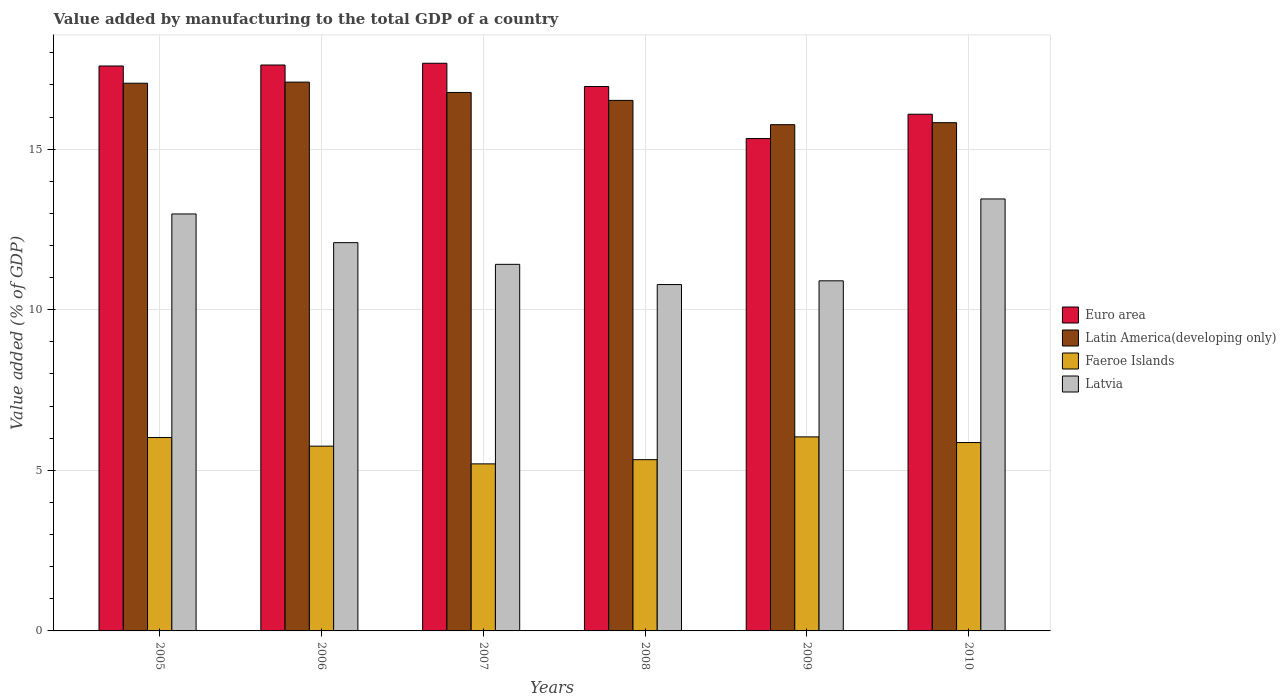How many bars are there on the 4th tick from the left?
Offer a very short reply. 4. How many bars are there on the 4th tick from the right?
Your answer should be compact. 4. What is the value added by manufacturing to the total GDP in Faeroe Islands in 2005?
Keep it short and to the point. 6.02. Across all years, what is the maximum value added by manufacturing to the total GDP in Faeroe Islands?
Provide a succinct answer. 6.04. Across all years, what is the minimum value added by manufacturing to the total GDP in Latin America(developing only)?
Keep it short and to the point. 15.76. In which year was the value added by manufacturing to the total GDP in Latin America(developing only) maximum?
Ensure brevity in your answer.  2006. What is the total value added by manufacturing to the total GDP in Latin America(developing only) in the graph?
Ensure brevity in your answer.  99. What is the difference between the value added by manufacturing to the total GDP in Latin America(developing only) in 2006 and that in 2008?
Make the answer very short. 0.57. What is the difference between the value added by manufacturing to the total GDP in Euro area in 2010 and the value added by manufacturing to the total GDP in Latvia in 2009?
Your answer should be very brief. 5.19. What is the average value added by manufacturing to the total GDP in Faeroe Islands per year?
Make the answer very short. 5.7. In the year 2007, what is the difference between the value added by manufacturing to the total GDP in Latvia and value added by manufacturing to the total GDP in Faeroe Islands?
Your response must be concise. 6.21. What is the ratio of the value added by manufacturing to the total GDP in Euro area in 2007 to that in 2009?
Offer a very short reply. 1.15. What is the difference between the highest and the second highest value added by manufacturing to the total GDP in Euro area?
Keep it short and to the point. 0.05. What is the difference between the highest and the lowest value added by manufacturing to the total GDP in Euro area?
Your answer should be very brief. 2.34. In how many years, is the value added by manufacturing to the total GDP in Latvia greater than the average value added by manufacturing to the total GDP in Latvia taken over all years?
Ensure brevity in your answer.  3. Is the sum of the value added by manufacturing to the total GDP in Euro area in 2005 and 2006 greater than the maximum value added by manufacturing to the total GDP in Faeroe Islands across all years?
Make the answer very short. Yes. What does the 4th bar from the left in 2008 represents?
Keep it short and to the point. Latvia. What does the 3rd bar from the right in 2006 represents?
Your response must be concise. Latin America(developing only). Is it the case that in every year, the sum of the value added by manufacturing to the total GDP in Latin America(developing only) and value added by manufacturing to the total GDP in Euro area is greater than the value added by manufacturing to the total GDP in Latvia?
Ensure brevity in your answer.  Yes. What is the difference between two consecutive major ticks on the Y-axis?
Ensure brevity in your answer.  5. Are the values on the major ticks of Y-axis written in scientific E-notation?
Keep it short and to the point. No. Does the graph contain any zero values?
Your answer should be very brief. No. Where does the legend appear in the graph?
Keep it short and to the point. Center right. How many legend labels are there?
Your response must be concise. 4. How are the legend labels stacked?
Provide a succinct answer. Vertical. What is the title of the graph?
Your answer should be very brief. Value added by manufacturing to the total GDP of a country. What is the label or title of the Y-axis?
Your answer should be compact. Value added (% of GDP). What is the Value added (% of GDP) of Euro area in 2005?
Provide a short and direct response. 17.59. What is the Value added (% of GDP) in Latin America(developing only) in 2005?
Provide a short and direct response. 17.05. What is the Value added (% of GDP) in Faeroe Islands in 2005?
Your answer should be very brief. 6.02. What is the Value added (% of GDP) in Latvia in 2005?
Offer a very short reply. 12.98. What is the Value added (% of GDP) of Euro area in 2006?
Make the answer very short. 17.62. What is the Value added (% of GDP) of Latin America(developing only) in 2006?
Your answer should be very brief. 17.09. What is the Value added (% of GDP) in Faeroe Islands in 2006?
Your response must be concise. 5.75. What is the Value added (% of GDP) of Latvia in 2006?
Give a very brief answer. 12.09. What is the Value added (% of GDP) in Euro area in 2007?
Keep it short and to the point. 17.67. What is the Value added (% of GDP) in Latin America(developing only) in 2007?
Offer a very short reply. 16.76. What is the Value added (% of GDP) in Faeroe Islands in 2007?
Your answer should be compact. 5.2. What is the Value added (% of GDP) in Latvia in 2007?
Keep it short and to the point. 11.41. What is the Value added (% of GDP) in Euro area in 2008?
Make the answer very short. 16.95. What is the Value added (% of GDP) in Latin America(developing only) in 2008?
Offer a very short reply. 16.52. What is the Value added (% of GDP) of Faeroe Islands in 2008?
Provide a succinct answer. 5.33. What is the Value added (% of GDP) in Latvia in 2008?
Make the answer very short. 10.78. What is the Value added (% of GDP) of Euro area in 2009?
Give a very brief answer. 15.33. What is the Value added (% of GDP) of Latin America(developing only) in 2009?
Give a very brief answer. 15.76. What is the Value added (% of GDP) of Faeroe Islands in 2009?
Your answer should be compact. 6.04. What is the Value added (% of GDP) of Latvia in 2009?
Keep it short and to the point. 10.9. What is the Value added (% of GDP) of Euro area in 2010?
Provide a short and direct response. 16.09. What is the Value added (% of GDP) of Latin America(developing only) in 2010?
Offer a very short reply. 15.82. What is the Value added (% of GDP) in Faeroe Islands in 2010?
Your answer should be very brief. 5.86. What is the Value added (% of GDP) in Latvia in 2010?
Your answer should be compact. 13.45. Across all years, what is the maximum Value added (% of GDP) in Euro area?
Make the answer very short. 17.67. Across all years, what is the maximum Value added (% of GDP) of Latin America(developing only)?
Provide a short and direct response. 17.09. Across all years, what is the maximum Value added (% of GDP) in Faeroe Islands?
Ensure brevity in your answer.  6.04. Across all years, what is the maximum Value added (% of GDP) of Latvia?
Keep it short and to the point. 13.45. Across all years, what is the minimum Value added (% of GDP) in Euro area?
Provide a short and direct response. 15.33. Across all years, what is the minimum Value added (% of GDP) of Latin America(developing only)?
Your response must be concise. 15.76. Across all years, what is the minimum Value added (% of GDP) of Faeroe Islands?
Your response must be concise. 5.2. Across all years, what is the minimum Value added (% of GDP) of Latvia?
Your answer should be compact. 10.78. What is the total Value added (% of GDP) in Euro area in the graph?
Offer a terse response. 101.24. What is the total Value added (% of GDP) of Latin America(developing only) in the graph?
Your answer should be compact. 99. What is the total Value added (% of GDP) of Faeroe Islands in the graph?
Provide a succinct answer. 34.21. What is the total Value added (% of GDP) in Latvia in the graph?
Provide a short and direct response. 71.62. What is the difference between the Value added (% of GDP) of Euro area in 2005 and that in 2006?
Your response must be concise. -0.03. What is the difference between the Value added (% of GDP) of Latin America(developing only) in 2005 and that in 2006?
Provide a succinct answer. -0.03. What is the difference between the Value added (% of GDP) of Faeroe Islands in 2005 and that in 2006?
Offer a terse response. 0.27. What is the difference between the Value added (% of GDP) in Latvia in 2005 and that in 2006?
Offer a very short reply. 0.89. What is the difference between the Value added (% of GDP) of Euro area in 2005 and that in 2007?
Offer a very short reply. -0.09. What is the difference between the Value added (% of GDP) of Latin America(developing only) in 2005 and that in 2007?
Your response must be concise. 0.29. What is the difference between the Value added (% of GDP) in Faeroe Islands in 2005 and that in 2007?
Your answer should be very brief. 0.82. What is the difference between the Value added (% of GDP) in Latvia in 2005 and that in 2007?
Your answer should be compact. 1.57. What is the difference between the Value added (% of GDP) of Euro area in 2005 and that in 2008?
Give a very brief answer. 0.64. What is the difference between the Value added (% of GDP) of Latin America(developing only) in 2005 and that in 2008?
Offer a terse response. 0.53. What is the difference between the Value added (% of GDP) in Faeroe Islands in 2005 and that in 2008?
Make the answer very short. 0.69. What is the difference between the Value added (% of GDP) of Latvia in 2005 and that in 2008?
Offer a terse response. 2.2. What is the difference between the Value added (% of GDP) of Euro area in 2005 and that in 2009?
Give a very brief answer. 2.26. What is the difference between the Value added (% of GDP) of Latin America(developing only) in 2005 and that in 2009?
Your answer should be compact. 1.29. What is the difference between the Value added (% of GDP) of Faeroe Islands in 2005 and that in 2009?
Give a very brief answer. -0.02. What is the difference between the Value added (% of GDP) in Latvia in 2005 and that in 2009?
Ensure brevity in your answer.  2.08. What is the difference between the Value added (% of GDP) of Euro area in 2005 and that in 2010?
Offer a terse response. 1.5. What is the difference between the Value added (% of GDP) in Latin America(developing only) in 2005 and that in 2010?
Your response must be concise. 1.23. What is the difference between the Value added (% of GDP) in Faeroe Islands in 2005 and that in 2010?
Provide a short and direct response. 0.16. What is the difference between the Value added (% of GDP) of Latvia in 2005 and that in 2010?
Provide a short and direct response. -0.47. What is the difference between the Value added (% of GDP) in Euro area in 2006 and that in 2007?
Your answer should be very brief. -0.05. What is the difference between the Value added (% of GDP) in Latin America(developing only) in 2006 and that in 2007?
Offer a terse response. 0.32. What is the difference between the Value added (% of GDP) in Faeroe Islands in 2006 and that in 2007?
Provide a succinct answer. 0.55. What is the difference between the Value added (% of GDP) of Latvia in 2006 and that in 2007?
Your answer should be compact. 0.68. What is the difference between the Value added (% of GDP) in Euro area in 2006 and that in 2008?
Your answer should be very brief. 0.67. What is the difference between the Value added (% of GDP) of Latin America(developing only) in 2006 and that in 2008?
Make the answer very short. 0.57. What is the difference between the Value added (% of GDP) of Faeroe Islands in 2006 and that in 2008?
Offer a very short reply. 0.42. What is the difference between the Value added (% of GDP) of Latvia in 2006 and that in 2008?
Your answer should be very brief. 1.3. What is the difference between the Value added (% of GDP) of Euro area in 2006 and that in 2009?
Make the answer very short. 2.29. What is the difference between the Value added (% of GDP) in Latin America(developing only) in 2006 and that in 2009?
Offer a terse response. 1.33. What is the difference between the Value added (% of GDP) in Faeroe Islands in 2006 and that in 2009?
Your answer should be very brief. -0.29. What is the difference between the Value added (% of GDP) in Latvia in 2006 and that in 2009?
Keep it short and to the point. 1.19. What is the difference between the Value added (% of GDP) in Euro area in 2006 and that in 2010?
Keep it short and to the point. 1.53. What is the difference between the Value added (% of GDP) in Latin America(developing only) in 2006 and that in 2010?
Provide a short and direct response. 1.26. What is the difference between the Value added (% of GDP) in Faeroe Islands in 2006 and that in 2010?
Offer a terse response. -0.11. What is the difference between the Value added (% of GDP) in Latvia in 2006 and that in 2010?
Offer a terse response. -1.36. What is the difference between the Value added (% of GDP) of Euro area in 2007 and that in 2008?
Provide a succinct answer. 0.72. What is the difference between the Value added (% of GDP) of Latin America(developing only) in 2007 and that in 2008?
Your response must be concise. 0.25. What is the difference between the Value added (% of GDP) of Faeroe Islands in 2007 and that in 2008?
Offer a very short reply. -0.13. What is the difference between the Value added (% of GDP) in Latvia in 2007 and that in 2008?
Offer a very short reply. 0.63. What is the difference between the Value added (% of GDP) of Euro area in 2007 and that in 2009?
Offer a terse response. 2.34. What is the difference between the Value added (% of GDP) in Latin America(developing only) in 2007 and that in 2009?
Offer a very short reply. 1. What is the difference between the Value added (% of GDP) in Faeroe Islands in 2007 and that in 2009?
Make the answer very short. -0.84. What is the difference between the Value added (% of GDP) of Latvia in 2007 and that in 2009?
Make the answer very short. 0.51. What is the difference between the Value added (% of GDP) in Euro area in 2007 and that in 2010?
Your answer should be very brief. 1.59. What is the difference between the Value added (% of GDP) in Latin America(developing only) in 2007 and that in 2010?
Ensure brevity in your answer.  0.94. What is the difference between the Value added (% of GDP) in Faeroe Islands in 2007 and that in 2010?
Offer a terse response. -0.66. What is the difference between the Value added (% of GDP) of Latvia in 2007 and that in 2010?
Your answer should be very brief. -2.04. What is the difference between the Value added (% of GDP) in Euro area in 2008 and that in 2009?
Your response must be concise. 1.62. What is the difference between the Value added (% of GDP) in Latin America(developing only) in 2008 and that in 2009?
Ensure brevity in your answer.  0.76. What is the difference between the Value added (% of GDP) of Faeroe Islands in 2008 and that in 2009?
Offer a terse response. -0.71. What is the difference between the Value added (% of GDP) in Latvia in 2008 and that in 2009?
Give a very brief answer. -0.12. What is the difference between the Value added (% of GDP) of Euro area in 2008 and that in 2010?
Keep it short and to the point. 0.86. What is the difference between the Value added (% of GDP) of Latin America(developing only) in 2008 and that in 2010?
Your answer should be very brief. 0.69. What is the difference between the Value added (% of GDP) of Faeroe Islands in 2008 and that in 2010?
Your answer should be very brief. -0.53. What is the difference between the Value added (% of GDP) of Latvia in 2008 and that in 2010?
Provide a short and direct response. -2.66. What is the difference between the Value added (% of GDP) in Euro area in 2009 and that in 2010?
Offer a terse response. -0.76. What is the difference between the Value added (% of GDP) of Latin America(developing only) in 2009 and that in 2010?
Your answer should be very brief. -0.06. What is the difference between the Value added (% of GDP) of Faeroe Islands in 2009 and that in 2010?
Provide a succinct answer. 0.18. What is the difference between the Value added (% of GDP) of Latvia in 2009 and that in 2010?
Your answer should be very brief. -2.55. What is the difference between the Value added (% of GDP) of Euro area in 2005 and the Value added (% of GDP) of Latin America(developing only) in 2006?
Keep it short and to the point. 0.5. What is the difference between the Value added (% of GDP) of Euro area in 2005 and the Value added (% of GDP) of Faeroe Islands in 2006?
Provide a succinct answer. 11.84. What is the difference between the Value added (% of GDP) in Euro area in 2005 and the Value added (% of GDP) in Latvia in 2006?
Provide a succinct answer. 5.5. What is the difference between the Value added (% of GDP) in Latin America(developing only) in 2005 and the Value added (% of GDP) in Faeroe Islands in 2006?
Provide a short and direct response. 11.3. What is the difference between the Value added (% of GDP) of Latin America(developing only) in 2005 and the Value added (% of GDP) of Latvia in 2006?
Your answer should be very brief. 4.96. What is the difference between the Value added (% of GDP) in Faeroe Islands in 2005 and the Value added (% of GDP) in Latvia in 2006?
Make the answer very short. -6.07. What is the difference between the Value added (% of GDP) in Euro area in 2005 and the Value added (% of GDP) in Latin America(developing only) in 2007?
Your answer should be very brief. 0.82. What is the difference between the Value added (% of GDP) of Euro area in 2005 and the Value added (% of GDP) of Faeroe Islands in 2007?
Your answer should be compact. 12.39. What is the difference between the Value added (% of GDP) in Euro area in 2005 and the Value added (% of GDP) in Latvia in 2007?
Offer a terse response. 6.18. What is the difference between the Value added (% of GDP) of Latin America(developing only) in 2005 and the Value added (% of GDP) of Faeroe Islands in 2007?
Make the answer very short. 11.85. What is the difference between the Value added (% of GDP) in Latin America(developing only) in 2005 and the Value added (% of GDP) in Latvia in 2007?
Your answer should be compact. 5.64. What is the difference between the Value added (% of GDP) of Faeroe Islands in 2005 and the Value added (% of GDP) of Latvia in 2007?
Your answer should be compact. -5.39. What is the difference between the Value added (% of GDP) in Euro area in 2005 and the Value added (% of GDP) in Latin America(developing only) in 2008?
Your response must be concise. 1.07. What is the difference between the Value added (% of GDP) in Euro area in 2005 and the Value added (% of GDP) in Faeroe Islands in 2008?
Provide a short and direct response. 12.26. What is the difference between the Value added (% of GDP) in Euro area in 2005 and the Value added (% of GDP) in Latvia in 2008?
Give a very brief answer. 6.8. What is the difference between the Value added (% of GDP) in Latin America(developing only) in 2005 and the Value added (% of GDP) in Faeroe Islands in 2008?
Your answer should be compact. 11.72. What is the difference between the Value added (% of GDP) of Latin America(developing only) in 2005 and the Value added (% of GDP) of Latvia in 2008?
Your answer should be compact. 6.27. What is the difference between the Value added (% of GDP) in Faeroe Islands in 2005 and the Value added (% of GDP) in Latvia in 2008?
Keep it short and to the point. -4.76. What is the difference between the Value added (% of GDP) in Euro area in 2005 and the Value added (% of GDP) in Latin America(developing only) in 2009?
Your response must be concise. 1.83. What is the difference between the Value added (% of GDP) of Euro area in 2005 and the Value added (% of GDP) of Faeroe Islands in 2009?
Provide a short and direct response. 11.55. What is the difference between the Value added (% of GDP) of Euro area in 2005 and the Value added (% of GDP) of Latvia in 2009?
Offer a very short reply. 6.69. What is the difference between the Value added (% of GDP) of Latin America(developing only) in 2005 and the Value added (% of GDP) of Faeroe Islands in 2009?
Make the answer very short. 11.01. What is the difference between the Value added (% of GDP) of Latin America(developing only) in 2005 and the Value added (% of GDP) of Latvia in 2009?
Your answer should be compact. 6.15. What is the difference between the Value added (% of GDP) of Faeroe Islands in 2005 and the Value added (% of GDP) of Latvia in 2009?
Your response must be concise. -4.88. What is the difference between the Value added (% of GDP) in Euro area in 2005 and the Value added (% of GDP) in Latin America(developing only) in 2010?
Your response must be concise. 1.76. What is the difference between the Value added (% of GDP) of Euro area in 2005 and the Value added (% of GDP) of Faeroe Islands in 2010?
Your response must be concise. 11.72. What is the difference between the Value added (% of GDP) of Euro area in 2005 and the Value added (% of GDP) of Latvia in 2010?
Your answer should be compact. 4.14. What is the difference between the Value added (% of GDP) in Latin America(developing only) in 2005 and the Value added (% of GDP) in Faeroe Islands in 2010?
Offer a terse response. 11.19. What is the difference between the Value added (% of GDP) of Latin America(developing only) in 2005 and the Value added (% of GDP) of Latvia in 2010?
Provide a short and direct response. 3.6. What is the difference between the Value added (% of GDP) of Faeroe Islands in 2005 and the Value added (% of GDP) of Latvia in 2010?
Your response must be concise. -7.43. What is the difference between the Value added (% of GDP) in Euro area in 2006 and the Value added (% of GDP) in Latin America(developing only) in 2007?
Your response must be concise. 0.85. What is the difference between the Value added (% of GDP) of Euro area in 2006 and the Value added (% of GDP) of Faeroe Islands in 2007?
Offer a terse response. 12.42. What is the difference between the Value added (% of GDP) in Euro area in 2006 and the Value added (% of GDP) in Latvia in 2007?
Give a very brief answer. 6.21. What is the difference between the Value added (% of GDP) of Latin America(developing only) in 2006 and the Value added (% of GDP) of Faeroe Islands in 2007?
Make the answer very short. 11.89. What is the difference between the Value added (% of GDP) in Latin America(developing only) in 2006 and the Value added (% of GDP) in Latvia in 2007?
Your response must be concise. 5.67. What is the difference between the Value added (% of GDP) of Faeroe Islands in 2006 and the Value added (% of GDP) of Latvia in 2007?
Your answer should be very brief. -5.66. What is the difference between the Value added (% of GDP) in Euro area in 2006 and the Value added (% of GDP) in Latin America(developing only) in 2008?
Make the answer very short. 1.1. What is the difference between the Value added (% of GDP) of Euro area in 2006 and the Value added (% of GDP) of Faeroe Islands in 2008?
Offer a terse response. 12.29. What is the difference between the Value added (% of GDP) of Euro area in 2006 and the Value added (% of GDP) of Latvia in 2008?
Offer a terse response. 6.83. What is the difference between the Value added (% of GDP) in Latin America(developing only) in 2006 and the Value added (% of GDP) in Faeroe Islands in 2008?
Your answer should be very brief. 11.75. What is the difference between the Value added (% of GDP) of Latin America(developing only) in 2006 and the Value added (% of GDP) of Latvia in 2008?
Your answer should be compact. 6.3. What is the difference between the Value added (% of GDP) in Faeroe Islands in 2006 and the Value added (% of GDP) in Latvia in 2008?
Ensure brevity in your answer.  -5.03. What is the difference between the Value added (% of GDP) in Euro area in 2006 and the Value added (% of GDP) in Latin America(developing only) in 2009?
Keep it short and to the point. 1.86. What is the difference between the Value added (% of GDP) in Euro area in 2006 and the Value added (% of GDP) in Faeroe Islands in 2009?
Your response must be concise. 11.58. What is the difference between the Value added (% of GDP) in Euro area in 2006 and the Value added (% of GDP) in Latvia in 2009?
Make the answer very short. 6.72. What is the difference between the Value added (% of GDP) of Latin America(developing only) in 2006 and the Value added (% of GDP) of Faeroe Islands in 2009?
Keep it short and to the point. 11.05. What is the difference between the Value added (% of GDP) of Latin America(developing only) in 2006 and the Value added (% of GDP) of Latvia in 2009?
Your response must be concise. 6.19. What is the difference between the Value added (% of GDP) of Faeroe Islands in 2006 and the Value added (% of GDP) of Latvia in 2009?
Make the answer very short. -5.15. What is the difference between the Value added (% of GDP) of Euro area in 2006 and the Value added (% of GDP) of Latin America(developing only) in 2010?
Your answer should be compact. 1.8. What is the difference between the Value added (% of GDP) of Euro area in 2006 and the Value added (% of GDP) of Faeroe Islands in 2010?
Offer a terse response. 11.75. What is the difference between the Value added (% of GDP) in Euro area in 2006 and the Value added (% of GDP) in Latvia in 2010?
Keep it short and to the point. 4.17. What is the difference between the Value added (% of GDP) in Latin America(developing only) in 2006 and the Value added (% of GDP) in Faeroe Islands in 2010?
Keep it short and to the point. 11.22. What is the difference between the Value added (% of GDP) of Latin America(developing only) in 2006 and the Value added (% of GDP) of Latvia in 2010?
Keep it short and to the point. 3.64. What is the difference between the Value added (% of GDP) of Faeroe Islands in 2006 and the Value added (% of GDP) of Latvia in 2010?
Your answer should be very brief. -7.7. What is the difference between the Value added (% of GDP) in Euro area in 2007 and the Value added (% of GDP) in Latin America(developing only) in 2008?
Offer a very short reply. 1.16. What is the difference between the Value added (% of GDP) in Euro area in 2007 and the Value added (% of GDP) in Faeroe Islands in 2008?
Your answer should be compact. 12.34. What is the difference between the Value added (% of GDP) of Euro area in 2007 and the Value added (% of GDP) of Latvia in 2008?
Make the answer very short. 6.89. What is the difference between the Value added (% of GDP) of Latin America(developing only) in 2007 and the Value added (% of GDP) of Faeroe Islands in 2008?
Give a very brief answer. 11.43. What is the difference between the Value added (% of GDP) in Latin America(developing only) in 2007 and the Value added (% of GDP) in Latvia in 2008?
Make the answer very short. 5.98. What is the difference between the Value added (% of GDP) of Faeroe Islands in 2007 and the Value added (% of GDP) of Latvia in 2008?
Give a very brief answer. -5.58. What is the difference between the Value added (% of GDP) in Euro area in 2007 and the Value added (% of GDP) in Latin America(developing only) in 2009?
Offer a terse response. 1.91. What is the difference between the Value added (% of GDP) in Euro area in 2007 and the Value added (% of GDP) in Faeroe Islands in 2009?
Your answer should be compact. 11.63. What is the difference between the Value added (% of GDP) in Euro area in 2007 and the Value added (% of GDP) in Latvia in 2009?
Give a very brief answer. 6.77. What is the difference between the Value added (% of GDP) of Latin America(developing only) in 2007 and the Value added (% of GDP) of Faeroe Islands in 2009?
Provide a succinct answer. 10.72. What is the difference between the Value added (% of GDP) in Latin America(developing only) in 2007 and the Value added (% of GDP) in Latvia in 2009?
Offer a terse response. 5.86. What is the difference between the Value added (% of GDP) in Faeroe Islands in 2007 and the Value added (% of GDP) in Latvia in 2009?
Your answer should be very brief. -5.7. What is the difference between the Value added (% of GDP) of Euro area in 2007 and the Value added (% of GDP) of Latin America(developing only) in 2010?
Provide a short and direct response. 1.85. What is the difference between the Value added (% of GDP) in Euro area in 2007 and the Value added (% of GDP) in Faeroe Islands in 2010?
Keep it short and to the point. 11.81. What is the difference between the Value added (% of GDP) of Euro area in 2007 and the Value added (% of GDP) of Latvia in 2010?
Offer a terse response. 4.22. What is the difference between the Value added (% of GDP) of Latin America(developing only) in 2007 and the Value added (% of GDP) of Faeroe Islands in 2010?
Ensure brevity in your answer.  10.9. What is the difference between the Value added (% of GDP) in Latin America(developing only) in 2007 and the Value added (% of GDP) in Latvia in 2010?
Keep it short and to the point. 3.32. What is the difference between the Value added (% of GDP) of Faeroe Islands in 2007 and the Value added (% of GDP) of Latvia in 2010?
Your response must be concise. -8.25. What is the difference between the Value added (% of GDP) of Euro area in 2008 and the Value added (% of GDP) of Latin America(developing only) in 2009?
Offer a very short reply. 1.19. What is the difference between the Value added (% of GDP) of Euro area in 2008 and the Value added (% of GDP) of Faeroe Islands in 2009?
Provide a short and direct response. 10.91. What is the difference between the Value added (% of GDP) of Euro area in 2008 and the Value added (% of GDP) of Latvia in 2009?
Provide a short and direct response. 6.05. What is the difference between the Value added (% of GDP) of Latin America(developing only) in 2008 and the Value added (% of GDP) of Faeroe Islands in 2009?
Ensure brevity in your answer.  10.48. What is the difference between the Value added (% of GDP) in Latin America(developing only) in 2008 and the Value added (% of GDP) in Latvia in 2009?
Your answer should be very brief. 5.62. What is the difference between the Value added (% of GDP) in Faeroe Islands in 2008 and the Value added (% of GDP) in Latvia in 2009?
Offer a terse response. -5.57. What is the difference between the Value added (% of GDP) of Euro area in 2008 and the Value added (% of GDP) of Latin America(developing only) in 2010?
Your answer should be compact. 1.13. What is the difference between the Value added (% of GDP) in Euro area in 2008 and the Value added (% of GDP) in Faeroe Islands in 2010?
Make the answer very short. 11.08. What is the difference between the Value added (% of GDP) of Euro area in 2008 and the Value added (% of GDP) of Latvia in 2010?
Your response must be concise. 3.5. What is the difference between the Value added (% of GDP) in Latin America(developing only) in 2008 and the Value added (% of GDP) in Faeroe Islands in 2010?
Your answer should be very brief. 10.65. What is the difference between the Value added (% of GDP) of Latin America(developing only) in 2008 and the Value added (% of GDP) of Latvia in 2010?
Keep it short and to the point. 3.07. What is the difference between the Value added (% of GDP) in Faeroe Islands in 2008 and the Value added (% of GDP) in Latvia in 2010?
Your answer should be compact. -8.12. What is the difference between the Value added (% of GDP) in Euro area in 2009 and the Value added (% of GDP) in Latin America(developing only) in 2010?
Your answer should be compact. -0.49. What is the difference between the Value added (% of GDP) of Euro area in 2009 and the Value added (% of GDP) of Faeroe Islands in 2010?
Give a very brief answer. 9.46. What is the difference between the Value added (% of GDP) of Euro area in 2009 and the Value added (% of GDP) of Latvia in 2010?
Ensure brevity in your answer.  1.88. What is the difference between the Value added (% of GDP) in Latin America(developing only) in 2009 and the Value added (% of GDP) in Faeroe Islands in 2010?
Offer a terse response. 9.9. What is the difference between the Value added (% of GDP) of Latin America(developing only) in 2009 and the Value added (% of GDP) of Latvia in 2010?
Offer a terse response. 2.31. What is the difference between the Value added (% of GDP) of Faeroe Islands in 2009 and the Value added (% of GDP) of Latvia in 2010?
Provide a succinct answer. -7.41. What is the average Value added (% of GDP) of Euro area per year?
Offer a terse response. 16.87. What is the average Value added (% of GDP) in Latin America(developing only) per year?
Ensure brevity in your answer.  16.5. What is the average Value added (% of GDP) in Faeroe Islands per year?
Make the answer very short. 5.7. What is the average Value added (% of GDP) of Latvia per year?
Provide a short and direct response. 11.94. In the year 2005, what is the difference between the Value added (% of GDP) in Euro area and Value added (% of GDP) in Latin America(developing only)?
Make the answer very short. 0.54. In the year 2005, what is the difference between the Value added (% of GDP) in Euro area and Value added (% of GDP) in Faeroe Islands?
Ensure brevity in your answer.  11.57. In the year 2005, what is the difference between the Value added (% of GDP) in Euro area and Value added (% of GDP) in Latvia?
Your answer should be compact. 4.61. In the year 2005, what is the difference between the Value added (% of GDP) in Latin America(developing only) and Value added (% of GDP) in Faeroe Islands?
Offer a very short reply. 11.03. In the year 2005, what is the difference between the Value added (% of GDP) in Latin America(developing only) and Value added (% of GDP) in Latvia?
Your answer should be very brief. 4.07. In the year 2005, what is the difference between the Value added (% of GDP) in Faeroe Islands and Value added (% of GDP) in Latvia?
Give a very brief answer. -6.96. In the year 2006, what is the difference between the Value added (% of GDP) in Euro area and Value added (% of GDP) in Latin America(developing only)?
Your answer should be very brief. 0.53. In the year 2006, what is the difference between the Value added (% of GDP) in Euro area and Value added (% of GDP) in Faeroe Islands?
Your answer should be very brief. 11.87. In the year 2006, what is the difference between the Value added (% of GDP) of Euro area and Value added (% of GDP) of Latvia?
Offer a very short reply. 5.53. In the year 2006, what is the difference between the Value added (% of GDP) of Latin America(developing only) and Value added (% of GDP) of Faeroe Islands?
Make the answer very short. 11.33. In the year 2006, what is the difference between the Value added (% of GDP) in Latin America(developing only) and Value added (% of GDP) in Latvia?
Give a very brief answer. 5. In the year 2006, what is the difference between the Value added (% of GDP) in Faeroe Islands and Value added (% of GDP) in Latvia?
Provide a succinct answer. -6.34. In the year 2007, what is the difference between the Value added (% of GDP) of Euro area and Value added (% of GDP) of Latin America(developing only)?
Your response must be concise. 0.91. In the year 2007, what is the difference between the Value added (% of GDP) in Euro area and Value added (% of GDP) in Faeroe Islands?
Make the answer very short. 12.47. In the year 2007, what is the difference between the Value added (% of GDP) of Euro area and Value added (% of GDP) of Latvia?
Your response must be concise. 6.26. In the year 2007, what is the difference between the Value added (% of GDP) of Latin America(developing only) and Value added (% of GDP) of Faeroe Islands?
Provide a short and direct response. 11.56. In the year 2007, what is the difference between the Value added (% of GDP) of Latin America(developing only) and Value added (% of GDP) of Latvia?
Your answer should be compact. 5.35. In the year 2007, what is the difference between the Value added (% of GDP) of Faeroe Islands and Value added (% of GDP) of Latvia?
Your answer should be compact. -6.21. In the year 2008, what is the difference between the Value added (% of GDP) in Euro area and Value added (% of GDP) in Latin America(developing only)?
Give a very brief answer. 0.43. In the year 2008, what is the difference between the Value added (% of GDP) of Euro area and Value added (% of GDP) of Faeroe Islands?
Keep it short and to the point. 11.62. In the year 2008, what is the difference between the Value added (% of GDP) of Euro area and Value added (% of GDP) of Latvia?
Provide a short and direct response. 6.17. In the year 2008, what is the difference between the Value added (% of GDP) in Latin America(developing only) and Value added (% of GDP) in Faeroe Islands?
Your answer should be compact. 11.19. In the year 2008, what is the difference between the Value added (% of GDP) of Latin America(developing only) and Value added (% of GDP) of Latvia?
Your answer should be very brief. 5.73. In the year 2008, what is the difference between the Value added (% of GDP) in Faeroe Islands and Value added (% of GDP) in Latvia?
Make the answer very short. -5.45. In the year 2009, what is the difference between the Value added (% of GDP) in Euro area and Value added (% of GDP) in Latin America(developing only)?
Your answer should be compact. -0.43. In the year 2009, what is the difference between the Value added (% of GDP) of Euro area and Value added (% of GDP) of Faeroe Islands?
Offer a very short reply. 9.29. In the year 2009, what is the difference between the Value added (% of GDP) of Euro area and Value added (% of GDP) of Latvia?
Provide a short and direct response. 4.43. In the year 2009, what is the difference between the Value added (% of GDP) of Latin America(developing only) and Value added (% of GDP) of Faeroe Islands?
Your answer should be compact. 9.72. In the year 2009, what is the difference between the Value added (% of GDP) in Latin America(developing only) and Value added (% of GDP) in Latvia?
Provide a short and direct response. 4.86. In the year 2009, what is the difference between the Value added (% of GDP) in Faeroe Islands and Value added (% of GDP) in Latvia?
Ensure brevity in your answer.  -4.86. In the year 2010, what is the difference between the Value added (% of GDP) of Euro area and Value added (% of GDP) of Latin America(developing only)?
Your response must be concise. 0.26. In the year 2010, what is the difference between the Value added (% of GDP) of Euro area and Value added (% of GDP) of Faeroe Islands?
Your response must be concise. 10.22. In the year 2010, what is the difference between the Value added (% of GDP) of Euro area and Value added (% of GDP) of Latvia?
Keep it short and to the point. 2.64. In the year 2010, what is the difference between the Value added (% of GDP) of Latin America(developing only) and Value added (% of GDP) of Faeroe Islands?
Offer a very short reply. 9.96. In the year 2010, what is the difference between the Value added (% of GDP) in Latin America(developing only) and Value added (% of GDP) in Latvia?
Your response must be concise. 2.38. In the year 2010, what is the difference between the Value added (% of GDP) in Faeroe Islands and Value added (% of GDP) in Latvia?
Your answer should be very brief. -7.58. What is the ratio of the Value added (% of GDP) of Latin America(developing only) in 2005 to that in 2006?
Make the answer very short. 1. What is the ratio of the Value added (% of GDP) of Faeroe Islands in 2005 to that in 2006?
Ensure brevity in your answer.  1.05. What is the ratio of the Value added (% of GDP) in Latvia in 2005 to that in 2006?
Ensure brevity in your answer.  1.07. What is the ratio of the Value added (% of GDP) in Latin America(developing only) in 2005 to that in 2007?
Keep it short and to the point. 1.02. What is the ratio of the Value added (% of GDP) of Faeroe Islands in 2005 to that in 2007?
Ensure brevity in your answer.  1.16. What is the ratio of the Value added (% of GDP) in Latvia in 2005 to that in 2007?
Give a very brief answer. 1.14. What is the ratio of the Value added (% of GDP) of Euro area in 2005 to that in 2008?
Offer a very short reply. 1.04. What is the ratio of the Value added (% of GDP) in Latin America(developing only) in 2005 to that in 2008?
Make the answer very short. 1.03. What is the ratio of the Value added (% of GDP) in Faeroe Islands in 2005 to that in 2008?
Give a very brief answer. 1.13. What is the ratio of the Value added (% of GDP) in Latvia in 2005 to that in 2008?
Your response must be concise. 1.2. What is the ratio of the Value added (% of GDP) in Euro area in 2005 to that in 2009?
Ensure brevity in your answer.  1.15. What is the ratio of the Value added (% of GDP) in Latin America(developing only) in 2005 to that in 2009?
Your answer should be very brief. 1.08. What is the ratio of the Value added (% of GDP) in Latvia in 2005 to that in 2009?
Provide a succinct answer. 1.19. What is the ratio of the Value added (% of GDP) of Euro area in 2005 to that in 2010?
Your answer should be compact. 1.09. What is the ratio of the Value added (% of GDP) in Latin America(developing only) in 2005 to that in 2010?
Your answer should be compact. 1.08. What is the ratio of the Value added (% of GDP) in Faeroe Islands in 2005 to that in 2010?
Your answer should be compact. 1.03. What is the ratio of the Value added (% of GDP) in Latvia in 2005 to that in 2010?
Give a very brief answer. 0.97. What is the ratio of the Value added (% of GDP) of Euro area in 2006 to that in 2007?
Ensure brevity in your answer.  1. What is the ratio of the Value added (% of GDP) of Latin America(developing only) in 2006 to that in 2007?
Give a very brief answer. 1.02. What is the ratio of the Value added (% of GDP) in Faeroe Islands in 2006 to that in 2007?
Your response must be concise. 1.11. What is the ratio of the Value added (% of GDP) of Latvia in 2006 to that in 2007?
Offer a very short reply. 1.06. What is the ratio of the Value added (% of GDP) of Euro area in 2006 to that in 2008?
Your answer should be very brief. 1.04. What is the ratio of the Value added (% of GDP) in Latin America(developing only) in 2006 to that in 2008?
Provide a short and direct response. 1.03. What is the ratio of the Value added (% of GDP) of Faeroe Islands in 2006 to that in 2008?
Offer a terse response. 1.08. What is the ratio of the Value added (% of GDP) of Latvia in 2006 to that in 2008?
Ensure brevity in your answer.  1.12. What is the ratio of the Value added (% of GDP) of Euro area in 2006 to that in 2009?
Ensure brevity in your answer.  1.15. What is the ratio of the Value added (% of GDP) of Latin America(developing only) in 2006 to that in 2009?
Provide a short and direct response. 1.08. What is the ratio of the Value added (% of GDP) of Faeroe Islands in 2006 to that in 2009?
Your response must be concise. 0.95. What is the ratio of the Value added (% of GDP) in Latvia in 2006 to that in 2009?
Offer a very short reply. 1.11. What is the ratio of the Value added (% of GDP) of Euro area in 2006 to that in 2010?
Provide a succinct answer. 1.1. What is the ratio of the Value added (% of GDP) of Latin America(developing only) in 2006 to that in 2010?
Provide a short and direct response. 1.08. What is the ratio of the Value added (% of GDP) in Faeroe Islands in 2006 to that in 2010?
Offer a terse response. 0.98. What is the ratio of the Value added (% of GDP) of Latvia in 2006 to that in 2010?
Offer a terse response. 0.9. What is the ratio of the Value added (% of GDP) in Euro area in 2007 to that in 2008?
Ensure brevity in your answer.  1.04. What is the ratio of the Value added (% of GDP) in Latin America(developing only) in 2007 to that in 2008?
Keep it short and to the point. 1.01. What is the ratio of the Value added (% of GDP) in Faeroe Islands in 2007 to that in 2008?
Offer a terse response. 0.98. What is the ratio of the Value added (% of GDP) in Latvia in 2007 to that in 2008?
Offer a terse response. 1.06. What is the ratio of the Value added (% of GDP) of Euro area in 2007 to that in 2009?
Offer a terse response. 1.15. What is the ratio of the Value added (% of GDP) of Latin America(developing only) in 2007 to that in 2009?
Your response must be concise. 1.06. What is the ratio of the Value added (% of GDP) in Faeroe Islands in 2007 to that in 2009?
Your answer should be compact. 0.86. What is the ratio of the Value added (% of GDP) in Latvia in 2007 to that in 2009?
Your answer should be very brief. 1.05. What is the ratio of the Value added (% of GDP) of Euro area in 2007 to that in 2010?
Provide a succinct answer. 1.1. What is the ratio of the Value added (% of GDP) in Latin America(developing only) in 2007 to that in 2010?
Offer a very short reply. 1.06. What is the ratio of the Value added (% of GDP) of Faeroe Islands in 2007 to that in 2010?
Ensure brevity in your answer.  0.89. What is the ratio of the Value added (% of GDP) of Latvia in 2007 to that in 2010?
Ensure brevity in your answer.  0.85. What is the ratio of the Value added (% of GDP) in Euro area in 2008 to that in 2009?
Your answer should be very brief. 1.11. What is the ratio of the Value added (% of GDP) in Latin America(developing only) in 2008 to that in 2009?
Your answer should be very brief. 1.05. What is the ratio of the Value added (% of GDP) in Faeroe Islands in 2008 to that in 2009?
Ensure brevity in your answer.  0.88. What is the ratio of the Value added (% of GDP) in Latvia in 2008 to that in 2009?
Your response must be concise. 0.99. What is the ratio of the Value added (% of GDP) in Euro area in 2008 to that in 2010?
Provide a short and direct response. 1.05. What is the ratio of the Value added (% of GDP) in Latin America(developing only) in 2008 to that in 2010?
Your response must be concise. 1.04. What is the ratio of the Value added (% of GDP) of Faeroe Islands in 2008 to that in 2010?
Your answer should be very brief. 0.91. What is the ratio of the Value added (% of GDP) of Latvia in 2008 to that in 2010?
Give a very brief answer. 0.8. What is the ratio of the Value added (% of GDP) of Euro area in 2009 to that in 2010?
Provide a short and direct response. 0.95. What is the ratio of the Value added (% of GDP) of Faeroe Islands in 2009 to that in 2010?
Make the answer very short. 1.03. What is the ratio of the Value added (% of GDP) in Latvia in 2009 to that in 2010?
Ensure brevity in your answer.  0.81. What is the difference between the highest and the second highest Value added (% of GDP) of Euro area?
Provide a short and direct response. 0.05. What is the difference between the highest and the second highest Value added (% of GDP) in Latin America(developing only)?
Provide a short and direct response. 0.03. What is the difference between the highest and the second highest Value added (% of GDP) of Faeroe Islands?
Provide a short and direct response. 0.02. What is the difference between the highest and the second highest Value added (% of GDP) in Latvia?
Your answer should be very brief. 0.47. What is the difference between the highest and the lowest Value added (% of GDP) in Euro area?
Your answer should be compact. 2.34. What is the difference between the highest and the lowest Value added (% of GDP) of Latin America(developing only)?
Give a very brief answer. 1.33. What is the difference between the highest and the lowest Value added (% of GDP) in Faeroe Islands?
Provide a succinct answer. 0.84. What is the difference between the highest and the lowest Value added (% of GDP) in Latvia?
Offer a very short reply. 2.66. 